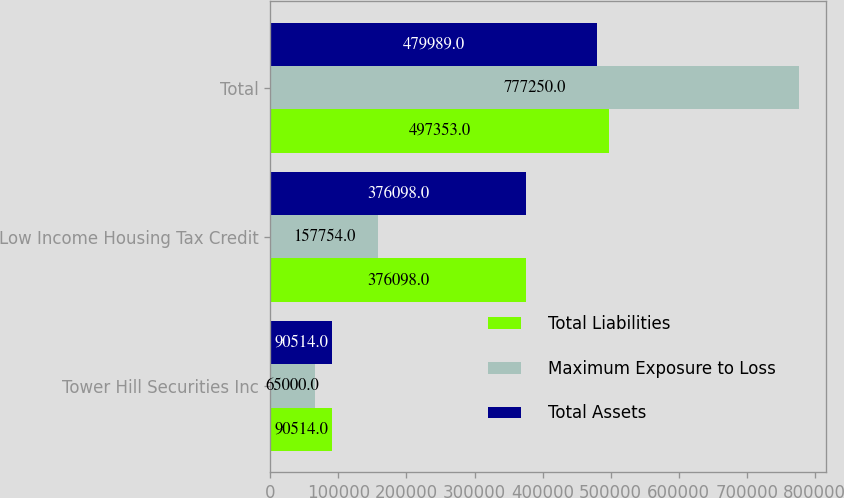Convert chart. <chart><loc_0><loc_0><loc_500><loc_500><stacked_bar_chart><ecel><fcel>Tower Hill Securities Inc<fcel>Low Income Housing Tax Credit<fcel>Total<nl><fcel>Total Liabilities<fcel>90514<fcel>376098<fcel>497353<nl><fcel>Maximum Exposure to Loss<fcel>65000<fcel>157754<fcel>777250<nl><fcel>Total Assets<fcel>90514<fcel>376098<fcel>479989<nl></chart> 